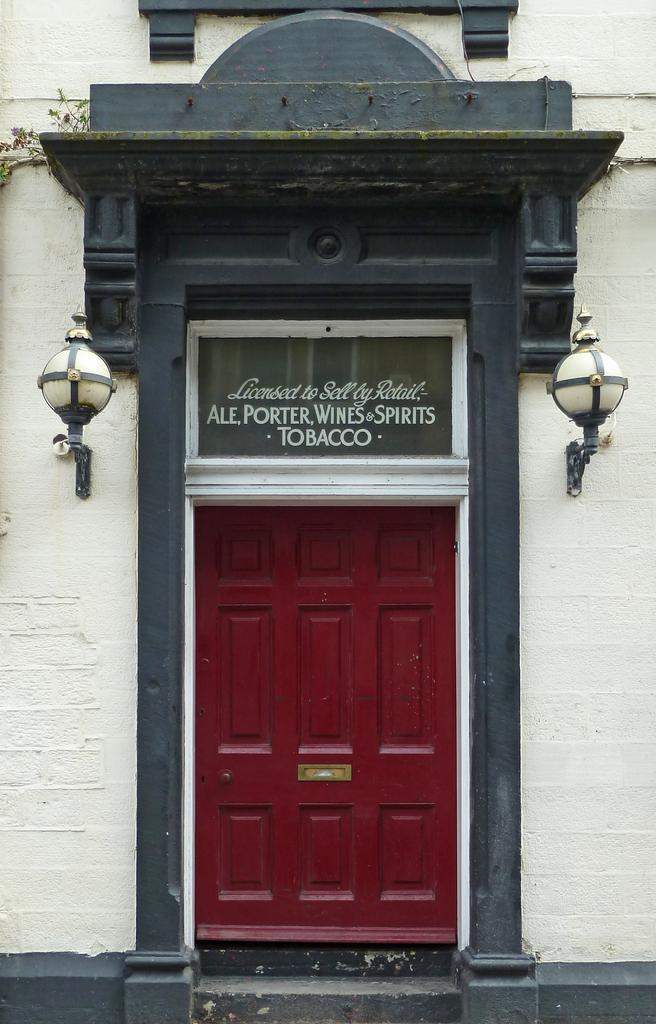What type of structure can be seen in the image? There is a wall in the image. What feature is present in the wall? There is a door in the image. What is attached to the wall in the image? There is a name board in the image. What type of illumination is present in the image? There are lights in the image. What type of transport is visible in the image? There is no transport visible in the image. What hour is depicted in the image? The image does not depict a specific hour; it only shows a wall, door, name board, and lights. 